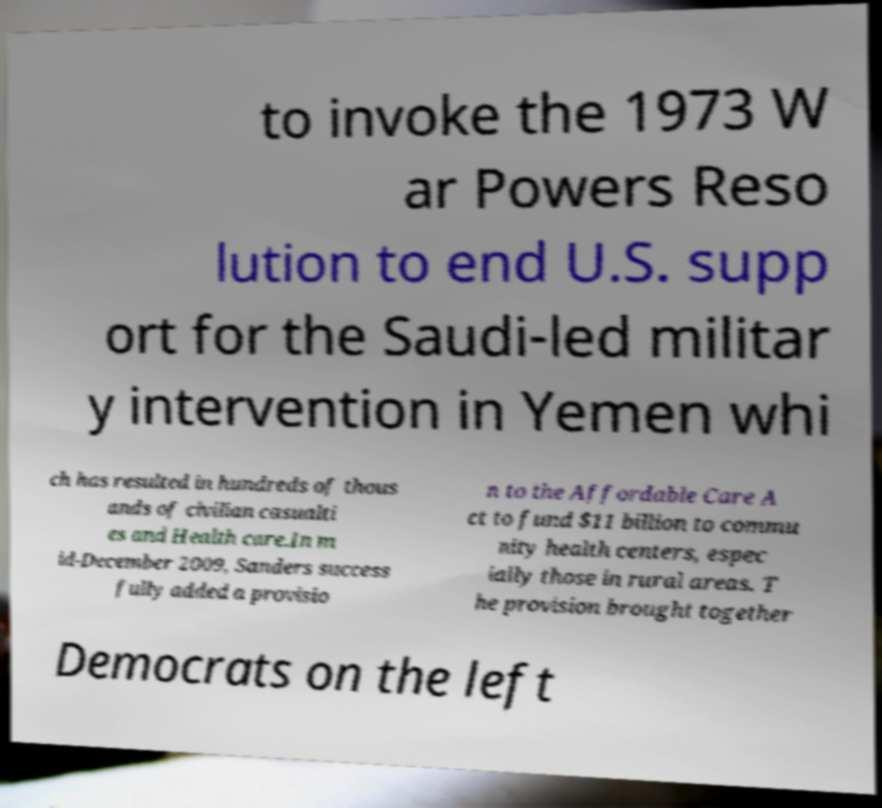I need the written content from this picture converted into text. Can you do that? to invoke the 1973 W ar Powers Reso lution to end U.S. supp ort for the Saudi-led militar y intervention in Yemen whi ch has resulted in hundreds of thous ands of civilian casualti es and Health care.In m id-December 2009, Sanders success fully added a provisio n to the Affordable Care A ct to fund $11 billion to commu nity health centers, espec ially those in rural areas. T he provision brought together Democrats on the left 